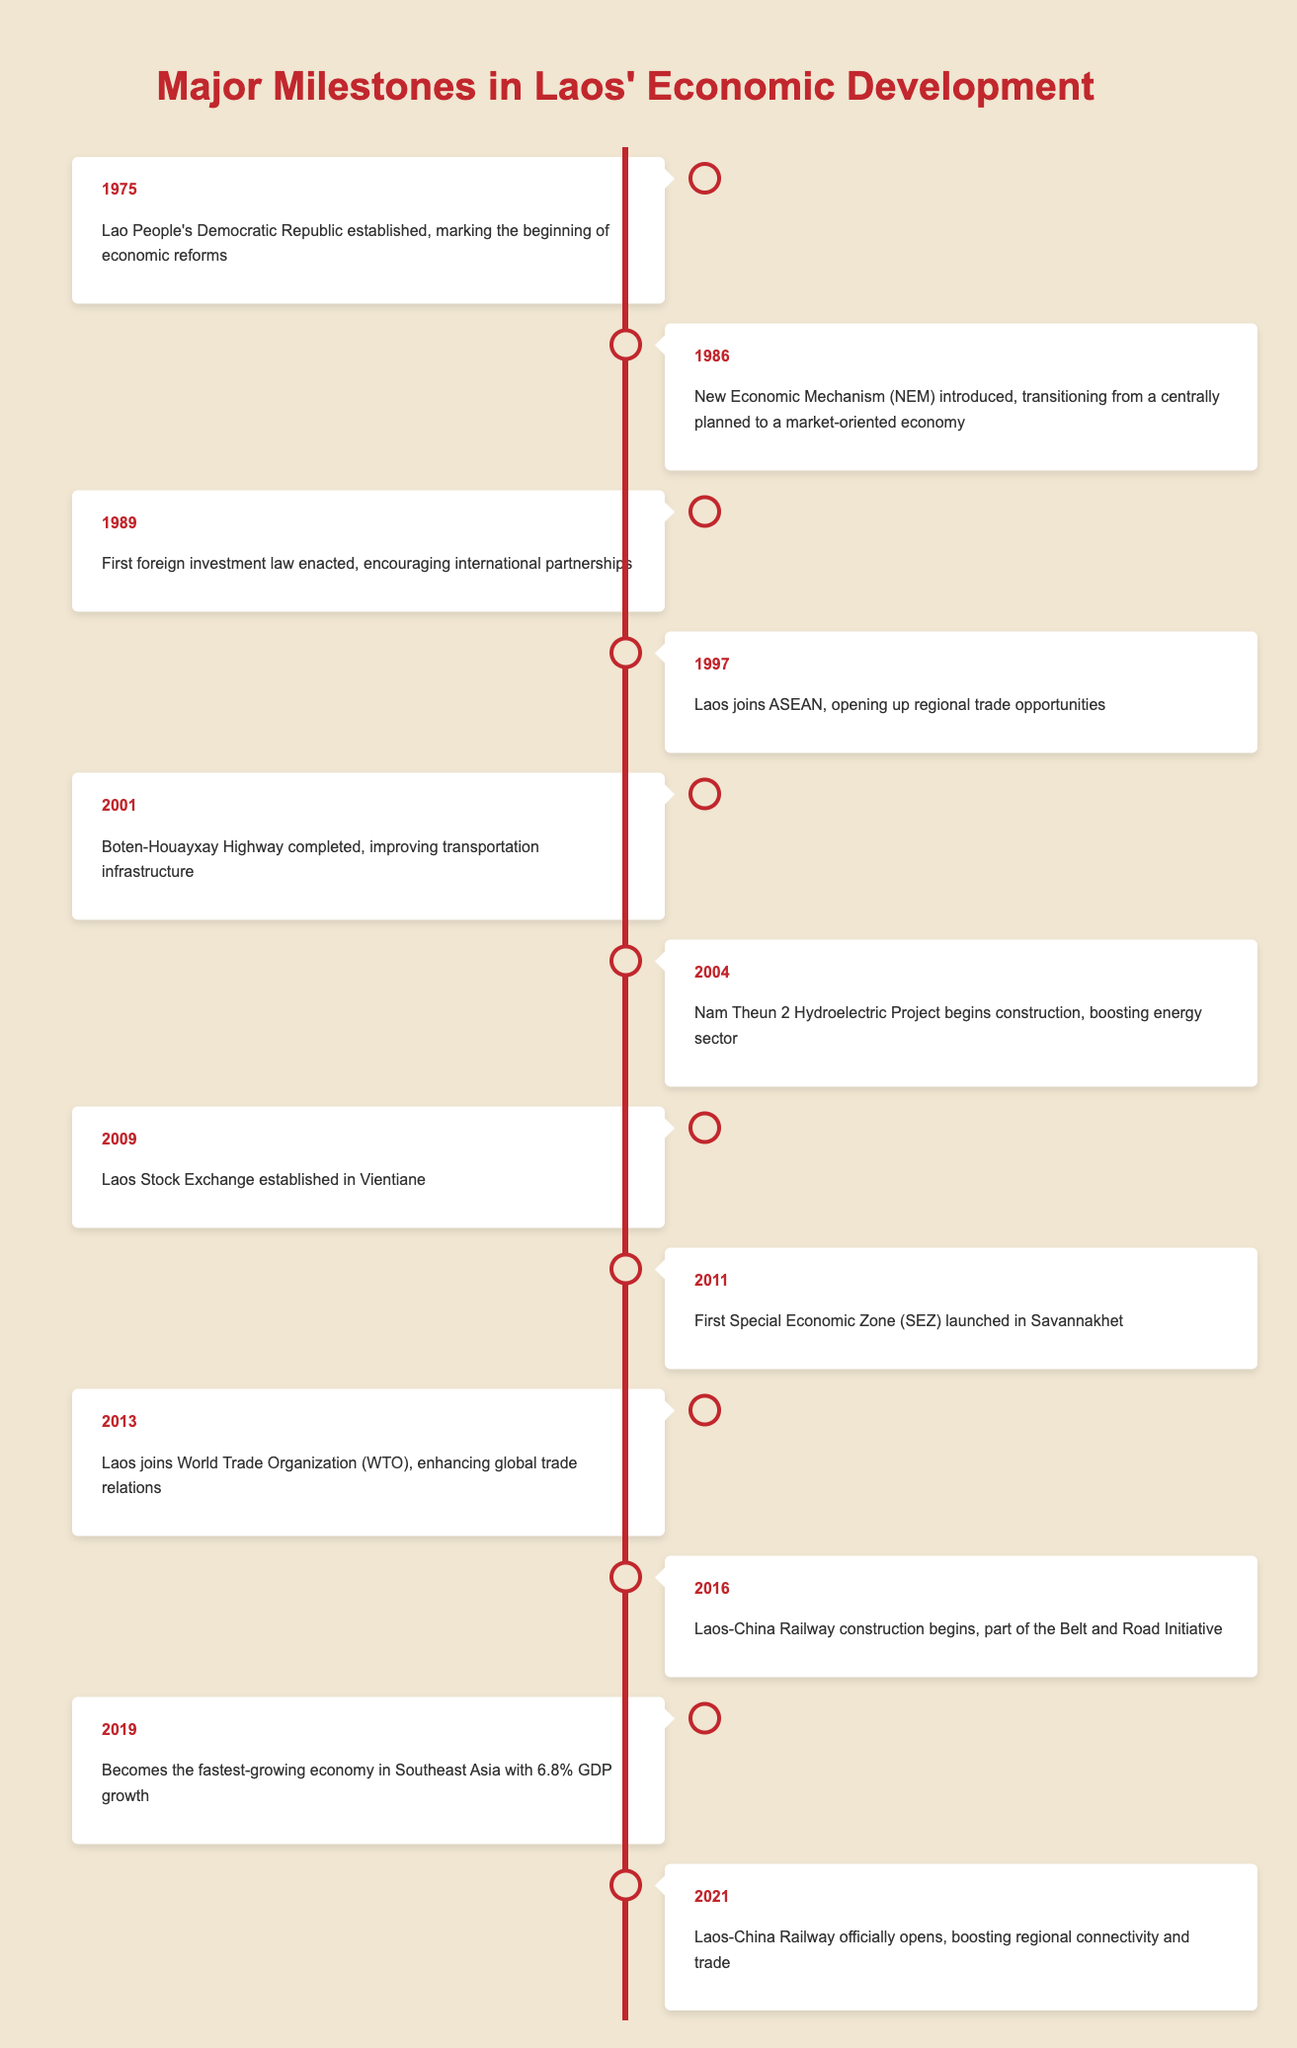What year was the Lao People's Democratic Republic established? The table shows that the Lao People's Democratic Republic was established in 1975. This is indicated as the first event in the timeline.
Answer: 1975 What significant economic reform was introduced in 1986? The event from 1986 states that the New Economic Mechanism (NEM) was introduced, marking a transition from a centrally planned economy to a market-oriented one.
Answer: New Economic Mechanism (NEM) Did Laos join ASEAN before or after 2000? According to the table, Laos joined ASEAN in 1997, which is before the year 2000. Therefore, the answer is after analyzing the date provided in the timeline.
Answer: Before How many years were there between the establishment of the Laos Stock Exchange and the launch of the first Special Economic Zone? The Laos Stock Exchange was established in 2009, and the first Special Economic Zone was launched in 2011. The difference between these years is 2011 - 2009 = 2 years. This highlights the timeframe between these two significant events.
Answer: 2 years Which year did Laos become the fastest-growing economy in Southeast Asia? The table indicates that in 2019, Laos became the fastest-growing economy in Southeast Asia, as stated in the corresponding event for that year.
Answer: 2019 Was the Nam Theun 2 Hydroelectric Project completed in 2004? The timeline only mentions that the construction of the Nam Theun 2 Hydroelectric Project began in 2004, but it does not confirm its completion date. Therefore, based on the information given, the statement is false.
Answer: No What are the two significant developments that occurred in 2016? In 2016, two significant events occurred: the construction of the Laos-China Railway began, which is part of the Belt and Road Initiative. These details can be found in the table under the year 2016.
Answer: Laos-China Railway construction In which year did Laos join the World Trade Organization (WTO)? The table notes that Laos joined the World Trade Organization in 2013. This is clearly stated in the entry for that year in the timeline.
Answer: 2013 How many milestones in Laos' economic development occurred between 2000 and 2010? The events listed in the table between 2000 and 2010 are from 2001 (Boten-Houayxay Highway completed), 2004 (Nam Theun 2 Hydroelectric Project begins), and 2009 (Laos Stock Exchange established). There are a total of 3 milestones noted in this timeframe.
Answer: 3 milestones 